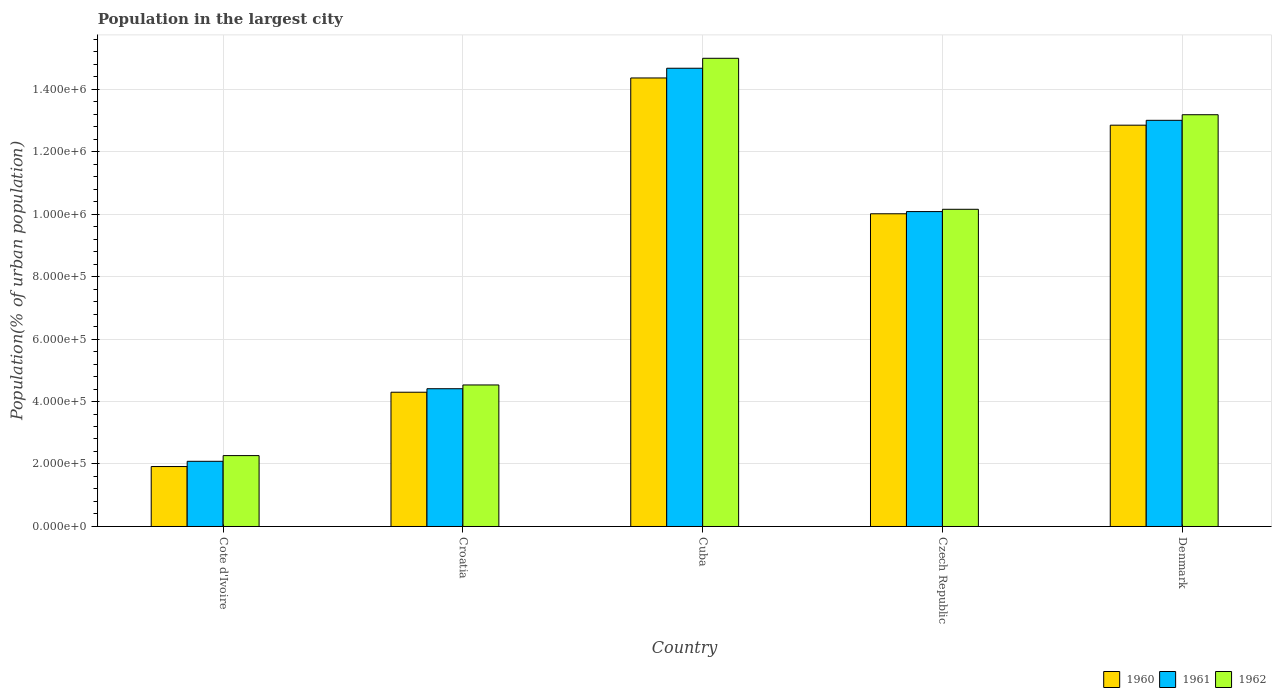Are the number of bars per tick equal to the number of legend labels?
Offer a very short reply. Yes. What is the label of the 3rd group of bars from the left?
Offer a very short reply. Cuba. In how many cases, is the number of bars for a given country not equal to the number of legend labels?
Give a very brief answer. 0. What is the population in the largest city in 1961 in Denmark?
Provide a succinct answer. 1.30e+06. Across all countries, what is the maximum population in the largest city in 1962?
Make the answer very short. 1.50e+06. Across all countries, what is the minimum population in the largest city in 1960?
Offer a very short reply. 1.92e+05. In which country was the population in the largest city in 1961 maximum?
Your response must be concise. Cuba. In which country was the population in the largest city in 1962 minimum?
Provide a succinct answer. Cote d'Ivoire. What is the total population in the largest city in 1960 in the graph?
Your response must be concise. 4.34e+06. What is the difference between the population in the largest city in 1961 in Cote d'Ivoire and that in Croatia?
Your response must be concise. -2.32e+05. What is the difference between the population in the largest city in 1961 in Czech Republic and the population in the largest city in 1960 in Cuba?
Make the answer very short. -4.28e+05. What is the average population in the largest city in 1960 per country?
Offer a very short reply. 8.68e+05. What is the difference between the population in the largest city of/in 1962 and population in the largest city of/in 1961 in Czech Republic?
Keep it short and to the point. 7379. What is the ratio of the population in the largest city in 1961 in Croatia to that in Czech Republic?
Ensure brevity in your answer.  0.44. Is the population in the largest city in 1962 in Cote d'Ivoire less than that in Croatia?
Make the answer very short. Yes. What is the difference between the highest and the second highest population in the largest city in 1961?
Keep it short and to the point. 4.59e+05. What is the difference between the highest and the lowest population in the largest city in 1960?
Offer a very short reply. 1.24e+06. Is the sum of the population in the largest city in 1961 in Croatia and Cuba greater than the maximum population in the largest city in 1960 across all countries?
Your response must be concise. Yes. What does the 3rd bar from the right in Czech Republic represents?
Give a very brief answer. 1960. How many countries are there in the graph?
Your response must be concise. 5. What is the difference between two consecutive major ticks on the Y-axis?
Provide a succinct answer. 2.00e+05. Does the graph contain any zero values?
Your response must be concise. No. Where does the legend appear in the graph?
Your answer should be compact. Bottom right. How many legend labels are there?
Your answer should be very brief. 3. How are the legend labels stacked?
Offer a very short reply. Horizontal. What is the title of the graph?
Your answer should be compact. Population in the largest city. What is the label or title of the Y-axis?
Provide a succinct answer. Population(% of urban population). What is the Population(% of urban population) in 1960 in Cote d'Ivoire?
Give a very brief answer. 1.92e+05. What is the Population(% of urban population) of 1961 in Cote d'Ivoire?
Provide a short and direct response. 2.09e+05. What is the Population(% of urban population) in 1962 in Cote d'Ivoire?
Your response must be concise. 2.27e+05. What is the Population(% of urban population) in 1960 in Croatia?
Offer a terse response. 4.30e+05. What is the Population(% of urban population) in 1961 in Croatia?
Your answer should be compact. 4.41e+05. What is the Population(% of urban population) in 1962 in Croatia?
Your answer should be compact. 4.53e+05. What is the Population(% of urban population) of 1960 in Cuba?
Ensure brevity in your answer.  1.44e+06. What is the Population(% of urban population) in 1961 in Cuba?
Keep it short and to the point. 1.47e+06. What is the Population(% of urban population) in 1962 in Cuba?
Your answer should be very brief. 1.50e+06. What is the Population(% of urban population) in 1960 in Czech Republic?
Your response must be concise. 1.00e+06. What is the Population(% of urban population) of 1961 in Czech Republic?
Provide a short and direct response. 1.01e+06. What is the Population(% of urban population) of 1962 in Czech Republic?
Keep it short and to the point. 1.02e+06. What is the Population(% of urban population) in 1960 in Denmark?
Your answer should be very brief. 1.28e+06. What is the Population(% of urban population) in 1961 in Denmark?
Provide a short and direct response. 1.30e+06. What is the Population(% of urban population) of 1962 in Denmark?
Offer a very short reply. 1.32e+06. Across all countries, what is the maximum Population(% of urban population) of 1960?
Your answer should be compact. 1.44e+06. Across all countries, what is the maximum Population(% of urban population) of 1961?
Your answer should be compact. 1.47e+06. Across all countries, what is the maximum Population(% of urban population) of 1962?
Your answer should be very brief. 1.50e+06. Across all countries, what is the minimum Population(% of urban population) in 1960?
Offer a terse response. 1.92e+05. Across all countries, what is the minimum Population(% of urban population) of 1961?
Your answer should be compact. 2.09e+05. Across all countries, what is the minimum Population(% of urban population) in 1962?
Provide a succinct answer. 2.27e+05. What is the total Population(% of urban population) of 1960 in the graph?
Provide a short and direct response. 4.34e+06. What is the total Population(% of urban population) of 1961 in the graph?
Your answer should be very brief. 4.42e+06. What is the total Population(% of urban population) in 1962 in the graph?
Offer a terse response. 4.51e+06. What is the difference between the Population(% of urban population) of 1960 in Cote d'Ivoire and that in Croatia?
Your response must be concise. -2.38e+05. What is the difference between the Population(% of urban population) of 1961 in Cote d'Ivoire and that in Croatia?
Your answer should be compact. -2.32e+05. What is the difference between the Population(% of urban population) of 1962 in Cote d'Ivoire and that in Croatia?
Make the answer very short. -2.26e+05. What is the difference between the Population(% of urban population) of 1960 in Cote d'Ivoire and that in Cuba?
Offer a terse response. -1.24e+06. What is the difference between the Population(% of urban population) in 1961 in Cote d'Ivoire and that in Cuba?
Provide a succinct answer. -1.26e+06. What is the difference between the Population(% of urban population) of 1962 in Cote d'Ivoire and that in Cuba?
Your answer should be very brief. -1.27e+06. What is the difference between the Population(% of urban population) of 1960 in Cote d'Ivoire and that in Czech Republic?
Ensure brevity in your answer.  -8.09e+05. What is the difference between the Population(% of urban population) of 1961 in Cote d'Ivoire and that in Czech Republic?
Your answer should be very brief. -7.99e+05. What is the difference between the Population(% of urban population) of 1962 in Cote d'Ivoire and that in Czech Republic?
Offer a very short reply. -7.88e+05. What is the difference between the Population(% of urban population) in 1960 in Cote d'Ivoire and that in Denmark?
Keep it short and to the point. -1.09e+06. What is the difference between the Population(% of urban population) of 1961 in Cote d'Ivoire and that in Denmark?
Your answer should be compact. -1.09e+06. What is the difference between the Population(% of urban population) in 1962 in Cote d'Ivoire and that in Denmark?
Make the answer very short. -1.09e+06. What is the difference between the Population(% of urban population) of 1960 in Croatia and that in Cuba?
Provide a short and direct response. -1.01e+06. What is the difference between the Population(% of urban population) of 1961 in Croatia and that in Cuba?
Your response must be concise. -1.03e+06. What is the difference between the Population(% of urban population) of 1962 in Croatia and that in Cuba?
Offer a very short reply. -1.05e+06. What is the difference between the Population(% of urban population) of 1960 in Croatia and that in Czech Republic?
Your answer should be very brief. -5.71e+05. What is the difference between the Population(% of urban population) of 1961 in Croatia and that in Czech Republic?
Make the answer very short. -5.67e+05. What is the difference between the Population(% of urban population) in 1962 in Croatia and that in Czech Republic?
Provide a succinct answer. -5.62e+05. What is the difference between the Population(% of urban population) in 1960 in Croatia and that in Denmark?
Your response must be concise. -8.55e+05. What is the difference between the Population(% of urban population) in 1961 in Croatia and that in Denmark?
Your answer should be compact. -8.59e+05. What is the difference between the Population(% of urban population) of 1962 in Croatia and that in Denmark?
Offer a terse response. -8.65e+05. What is the difference between the Population(% of urban population) of 1960 in Cuba and that in Czech Republic?
Provide a succinct answer. 4.35e+05. What is the difference between the Population(% of urban population) in 1961 in Cuba and that in Czech Republic?
Ensure brevity in your answer.  4.59e+05. What is the difference between the Population(% of urban population) in 1962 in Cuba and that in Czech Republic?
Provide a succinct answer. 4.83e+05. What is the difference between the Population(% of urban population) of 1960 in Cuba and that in Denmark?
Keep it short and to the point. 1.51e+05. What is the difference between the Population(% of urban population) of 1961 in Cuba and that in Denmark?
Provide a short and direct response. 1.67e+05. What is the difference between the Population(% of urban population) of 1962 in Cuba and that in Denmark?
Your answer should be very brief. 1.81e+05. What is the difference between the Population(% of urban population) of 1960 in Czech Republic and that in Denmark?
Ensure brevity in your answer.  -2.84e+05. What is the difference between the Population(% of urban population) of 1961 in Czech Republic and that in Denmark?
Your answer should be very brief. -2.92e+05. What is the difference between the Population(% of urban population) of 1962 in Czech Republic and that in Denmark?
Ensure brevity in your answer.  -3.03e+05. What is the difference between the Population(% of urban population) of 1960 in Cote d'Ivoire and the Population(% of urban population) of 1961 in Croatia?
Offer a terse response. -2.49e+05. What is the difference between the Population(% of urban population) of 1960 in Cote d'Ivoire and the Population(% of urban population) of 1962 in Croatia?
Keep it short and to the point. -2.61e+05. What is the difference between the Population(% of urban population) of 1961 in Cote d'Ivoire and the Population(% of urban population) of 1962 in Croatia?
Provide a short and direct response. -2.44e+05. What is the difference between the Population(% of urban population) in 1960 in Cote d'Ivoire and the Population(% of urban population) in 1961 in Cuba?
Provide a short and direct response. -1.27e+06. What is the difference between the Population(% of urban population) of 1960 in Cote d'Ivoire and the Population(% of urban population) of 1962 in Cuba?
Offer a terse response. -1.31e+06. What is the difference between the Population(% of urban population) of 1961 in Cote d'Ivoire and the Population(% of urban population) of 1962 in Cuba?
Provide a succinct answer. -1.29e+06. What is the difference between the Population(% of urban population) of 1960 in Cote d'Ivoire and the Population(% of urban population) of 1961 in Czech Republic?
Provide a short and direct response. -8.16e+05. What is the difference between the Population(% of urban population) in 1960 in Cote d'Ivoire and the Population(% of urban population) in 1962 in Czech Republic?
Provide a short and direct response. -8.23e+05. What is the difference between the Population(% of urban population) in 1961 in Cote d'Ivoire and the Population(% of urban population) in 1962 in Czech Republic?
Offer a terse response. -8.07e+05. What is the difference between the Population(% of urban population) in 1960 in Cote d'Ivoire and the Population(% of urban population) in 1961 in Denmark?
Provide a succinct answer. -1.11e+06. What is the difference between the Population(% of urban population) of 1960 in Cote d'Ivoire and the Population(% of urban population) of 1962 in Denmark?
Your answer should be compact. -1.13e+06. What is the difference between the Population(% of urban population) in 1961 in Cote d'Ivoire and the Population(% of urban population) in 1962 in Denmark?
Offer a terse response. -1.11e+06. What is the difference between the Population(% of urban population) of 1960 in Croatia and the Population(% of urban population) of 1961 in Cuba?
Offer a very short reply. -1.04e+06. What is the difference between the Population(% of urban population) of 1960 in Croatia and the Population(% of urban population) of 1962 in Cuba?
Provide a succinct answer. -1.07e+06. What is the difference between the Population(% of urban population) in 1961 in Croatia and the Population(% of urban population) in 1962 in Cuba?
Your answer should be very brief. -1.06e+06. What is the difference between the Population(% of urban population) of 1960 in Croatia and the Population(% of urban population) of 1961 in Czech Republic?
Keep it short and to the point. -5.78e+05. What is the difference between the Population(% of urban population) in 1960 in Croatia and the Population(% of urban population) in 1962 in Czech Republic?
Keep it short and to the point. -5.86e+05. What is the difference between the Population(% of urban population) of 1961 in Croatia and the Population(% of urban population) of 1962 in Czech Republic?
Make the answer very short. -5.74e+05. What is the difference between the Population(% of urban population) of 1960 in Croatia and the Population(% of urban population) of 1961 in Denmark?
Keep it short and to the point. -8.70e+05. What is the difference between the Population(% of urban population) in 1960 in Croatia and the Population(% of urban population) in 1962 in Denmark?
Offer a terse response. -8.88e+05. What is the difference between the Population(% of urban population) in 1961 in Croatia and the Population(% of urban population) in 1962 in Denmark?
Offer a very short reply. -8.77e+05. What is the difference between the Population(% of urban population) of 1960 in Cuba and the Population(% of urban population) of 1961 in Czech Republic?
Your response must be concise. 4.28e+05. What is the difference between the Population(% of urban population) of 1960 in Cuba and the Population(% of urban population) of 1962 in Czech Republic?
Give a very brief answer. 4.20e+05. What is the difference between the Population(% of urban population) of 1961 in Cuba and the Population(% of urban population) of 1962 in Czech Republic?
Your response must be concise. 4.51e+05. What is the difference between the Population(% of urban population) in 1960 in Cuba and the Population(% of urban population) in 1961 in Denmark?
Provide a succinct answer. 1.36e+05. What is the difference between the Population(% of urban population) of 1960 in Cuba and the Population(% of urban population) of 1962 in Denmark?
Offer a terse response. 1.18e+05. What is the difference between the Population(% of urban population) of 1961 in Cuba and the Population(% of urban population) of 1962 in Denmark?
Your answer should be compact. 1.49e+05. What is the difference between the Population(% of urban population) in 1960 in Czech Republic and the Population(% of urban population) in 1961 in Denmark?
Offer a very short reply. -2.99e+05. What is the difference between the Population(% of urban population) in 1960 in Czech Republic and the Population(% of urban population) in 1962 in Denmark?
Offer a terse response. -3.17e+05. What is the difference between the Population(% of urban population) of 1961 in Czech Republic and the Population(% of urban population) of 1962 in Denmark?
Your answer should be compact. -3.10e+05. What is the average Population(% of urban population) in 1960 per country?
Keep it short and to the point. 8.68e+05. What is the average Population(% of urban population) in 1961 per country?
Offer a terse response. 8.85e+05. What is the average Population(% of urban population) in 1962 per country?
Give a very brief answer. 9.02e+05. What is the difference between the Population(% of urban population) of 1960 and Population(% of urban population) of 1961 in Cote d'Ivoire?
Provide a succinct answer. -1.68e+04. What is the difference between the Population(% of urban population) in 1960 and Population(% of urban population) in 1962 in Cote d'Ivoire?
Ensure brevity in your answer.  -3.50e+04. What is the difference between the Population(% of urban population) in 1961 and Population(% of urban population) in 1962 in Cote d'Ivoire?
Your response must be concise. -1.82e+04. What is the difference between the Population(% of urban population) of 1960 and Population(% of urban population) of 1961 in Croatia?
Offer a very short reply. -1.12e+04. What is the difference between the Population(% of urban population) in 1960 and Population(% of urban population) in 1962 in Croatia?
Your response must be concise. -2.33e+04. What is the difference between the Population(% of urban population) in 1961 and Population(% of urban population) in 1962 in Croatia?
Your answer should be compact. -1.21e+04. What is the difference between the Population(% of urban population) in 1960 and Population(% of urban population) in 1961 in Cuba?
Ensure brevity in your answer.  -3.11e+04. What is the difference between the Population(% of urban population) of 1960 and Population(% of urban population) of 1962 in Cuba?
Your answer should be compact. -6.30e+04. What is the difference between the Population(% of urban population) in 1961 and Population(% of urban population) in 1962 in Cuba?
Your answer should be very brief. -3.18e+04. What is the difference between the Population(% of urban population) in 1960 and Population(% of urban population) in 1961 in Czech Republic?
Give a very brief answer. -7004. What is the difference between the Population(% of urban population) of 1960 and Population(% of urban population) of 1962 in Czech Republic?
Offer a very short reply. -1.44e+04. What is the difference between the Population(% of urban population) of 1961 and Population(% of urban population) of 1962 in Czech Republic?
Provide a succinct answer. -7379. What is the difference between the Population(% of urban population) in 1960 and Population(% of urban population) in 1961 in Denmark?
Keep it short and to the point. -1.55e+04. What is the difference between the Population(% of urban population) of 1960 and Population(% of urban population) of 1962 in Denmark?
Make the answer very short. -3.34e+04. What is the difference between the Population(% of urban population) of 1961 and Population(% of urban population) of 1962 in Denmark?
Ensure brevity in your answer.  -1.79e+04. What is the ratio of the Population(% of urban population) of 1960 in Cote d'Ivoire to that in Croatia?
Keep it short and to the point. 0.45. What is the ratio of the Population(% of urban population) of 1961 in Cote d'Ivoire to that in Croatia?
Keep it short and to the point. 0.47. What is the ratio of the Population(% of urban population) of 1962 in Cote d'Ivoire to that in Croatia?
Offer a terse response. 0.5. What is the ratio of the Population(% of urban population) of 1960 in Cote d'Ivoire to that in Cuba?
Provide a short and direct response. 0.13. What is the ratio of the Population(% of urban population) in 1961 in Cote d'Ivoire to that in Cuba?
Your response must be concise. 0.14. What is the ratio of the Population(% of urban population) in 1962 in Cote d'Ivoire to that in Cuba?
Provide a short and direct response. 0.15. What is the ratio of the Population(% of urban population) of 1960 in Cote d'Ivoire to that in Czech Republic?
Offer a very short reply. 0.19. What is the ratio of the Population(% of urban population) of 1961 in Cote d'Ivoire to that in Czech Republic?
Your answer should be very brief. 0.21. What is the ratio of the Population(% of urban population) of 1962 in Cote d'Ivoire to that in Czech Republic?
Provide a short and direct response. 0.22. What is the ratio of the Population(% of urban population) in 1960 in Cote d'Ivoire to that in Denmark?
Provide a short and direct response. 0.15. What is the ratio of the Population(% of urban population) of 1961 in Cote d'Ivoire to that in Denmark?
Your response must be concise. 0.16. What is the ratio of the Population(% of urban population) of 1962 in Cote d'Ivoire to that in Denmark?
Provide a succinct answer. 0.17. What is the ratio of the Population(% of urban population) of 1960 in Croatia to that in Cuba?
Give a very brief answer. 0.3. What is the ratio of the Population(% of urban population) of 1961 in Croatia to that in Cuba?
Keep it short and to the point. 0.3. What is the ratio of the Population(% of urban population) of 1962 in Croatia to that in Cuba?
Offer a terse response. 0.3. What is the ratio of the Population(% of urban population) in 1960 in Croatia to that in Czech Republic?
Provide a short and direct response. 0.43. What is the ratio of the Population(% of urban population) in 1961 in Croatia to that in Czech Republic?
Your answer should be very brief. 0.44. What is the ratio of the Population(% of urban population) in 1962 in Croatia to that in Czech Republic?
Give a very brief answer. 0.45. What is the ratio of the Population(% of urban population) in 1960 in Croatia to that in Denmark?
Provide a short and direct response. 0.33. What is the ratio of the Population(% of urban population) in 1961 in Croatia to that in Denmark?
Provide a short and direct response. 0.34. What is the ratio of the Population(% of urban population) of 1962 in Croatia to that in Denmark?
Ensure brevity in your answer.  0.34. What is the ratio of the Population(% of urban population) in 1960 in Cuba to that in Czech Republic?
Make the answer very short. 1.43. What is the ratio of the Population(% of urban population) in 1961 in Cuba to that in Czech Republic?
Provide a succinct answer. 1.46. What is the ratio of the Population(% of urban population) in 1962 in Cuba to that in Czech Republic?
Give a very brief answer. 1.48. What is the ratio of the Population(% of urban population) in 1960 in Cuba to that in Denmark?
Give a very brief answer. 1.12. What is the ratio of the Population(% of urban population) of 1961 in Cuba to that in Denmark?
Your answer should be very brief. 1.13. What is the ratio of the Population(% of urban population) of 1962 in Cuba to that in Denmark?
Keep it short and to the point. 1.14. What is the ratio of the Population(% of urban population) in 1960 in Czech Republic to that in Denmark?
Keep it short and to the point. 0.78. What is the ratio of the Population(% of urban population) in 1961 in Czech Republic to that in Denmark?
Make the answer very short. 0.78. What is the ratio of the Population(% of urban population) of 1962 in Czech Republic to that in Denmark?
Keep it short and to the point. 0.77. What is the difference between the highest and the second highest Population(% of urban population) in 1960?
Offer a terse response. 1.51e+05. What is the difference between the highest and the second highest Population(% of urban population) in 1961?
Provide a short and direct response. 1.67e+05. What is the difference between the highest and the second highest Population(% of urban population) in 1962?
Make the answer very short. 1.81e+05. What is the difference between the highest and the lowest Population(% of urban population) of 1960?
Offer a very short reply. 1.24e+06. What is the difference between the highest and the lowest Population(% of urban population) of 1961?
Provide a succinct answer. 1.26e+06. What is the difference between the highest and the lowest Population(% of urban population) of 1962?
Provide a short and direct response. 1.27e+06. 